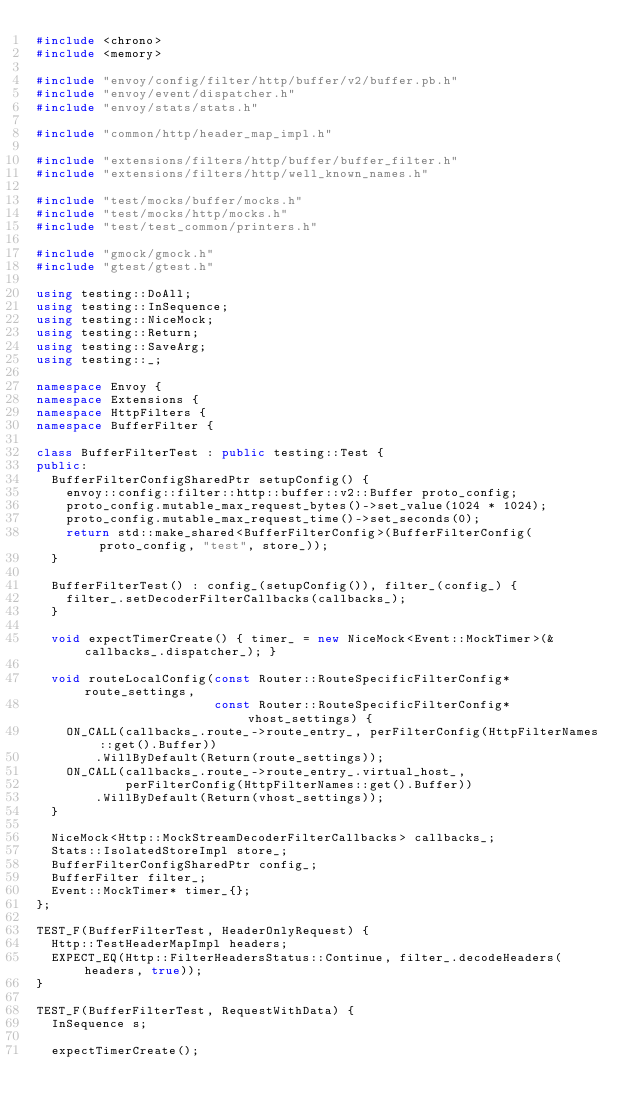Convert code to text. <code><loc_0><loc_0><loc_500><loc_500><_C++_>#include <chrono>
#include <memory>

#include "envoy/config/filter/http/buffer/v2/buffer.pb.h"
#include "envoy/event/dispatcher.h"
#include "envoy/stats/stats.h"

#include "common/http/header_map_impl.h"

#include "extensions/filters/http/buffer/buffer_filter.h"
#include "extensions/filters/http/well_known_names.h"

#include "test/mocks/buffer/mocks.h"
#include "test/mocks/http/mocks.h"
#include "test/test_common/printers.h"

#include "gmock/gmock.h"
#include "gtest/gtest.h"

using testing::DoAll;
using testing::InSequence;
using testing::NiceMock;
using testing::Return;
using testing::SaveArg;
using testing::_;

namespace Envoy {
namespace Extensions {
namespace HttpFilters {
namespace BufferFilter {

class BufferFilterTest : public testing::Test {
public:
  BufferFilterConfigSharedPtr setupConfig() {
    envoy::config::filter::http::buffer::v2::Buffer proto_config;
    proto_config.mutable_max_request_bytes()->set_value(1024 * 1024);
    proto_config.mutable_max_request_time()->set_seconds(0);
    return std::make_shared<BufferFilterConfig>(BufferFilterConfig(proto_config, "test", store_));
  }

  BufferFilterTest() : config_(setupConfig()), filter_(config_) {
    filter_.setDecoderFilterCallbacks(callbacks_);
  }

  void expectTimerCreate() { timer_ = new NiceMock<Event::MockTimer>(&callbacks_.dispatcher_); }

  void routeLocalConfig(const Router::RouteSpecificFilterConfig* route_settings,
                        const Router::RouteSpecificFilterConfig* vhost_settings) {
    ON_CALL(callbacks_.route_->route_entry_, perFilterConfig(HttpFilterNames::get().Buffer))
        .WillByDefault(Return(route_settings));
    ON_CALL(callbacks_.route_->route_entry_.virtual_host_,
            perFilterConfig(HttpFilterNames::get().Buffer))
        .WillByDefault(Return(vhost_settings));
  }

  NiceMock<Http::MockStreamDecoderFilterCallbacks> callbacks_;
  Stats::IsolatedStoreImpl store_;
  BufferFilterConfigSharedPtr config_;
  BufferFilter filter_;
  Event::MockTimer* timer_{};
};

TEST_F(BufferFilterTest, HeaderOnlyRequest) {
  Http::TestHeaderMapImpl headers;
  EXPECT_EQ(Http::FilterHeadersStatus::Continue, filter_.decodeHeaders(headers, true));
}

TEST_F(BufferFilterTest, RequestWithData) {
  InSequence s;

  expectTimerCreate();
</code> 